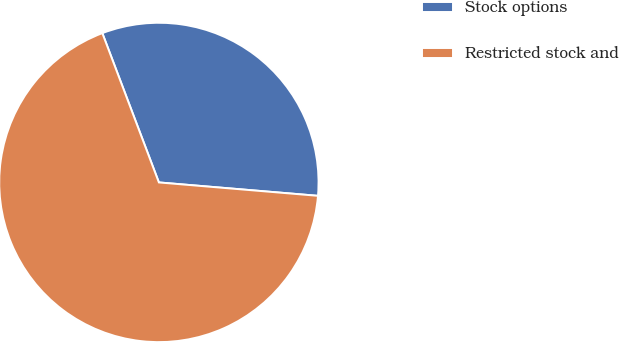Convert chart. <chart><loc_0><loc_0><loc_500><loc_500><pie_chart><fcel>Stock options<fcel>Restricted stock and<nl><fcel>32.1%<fcel>67.9%<nl></chart> 